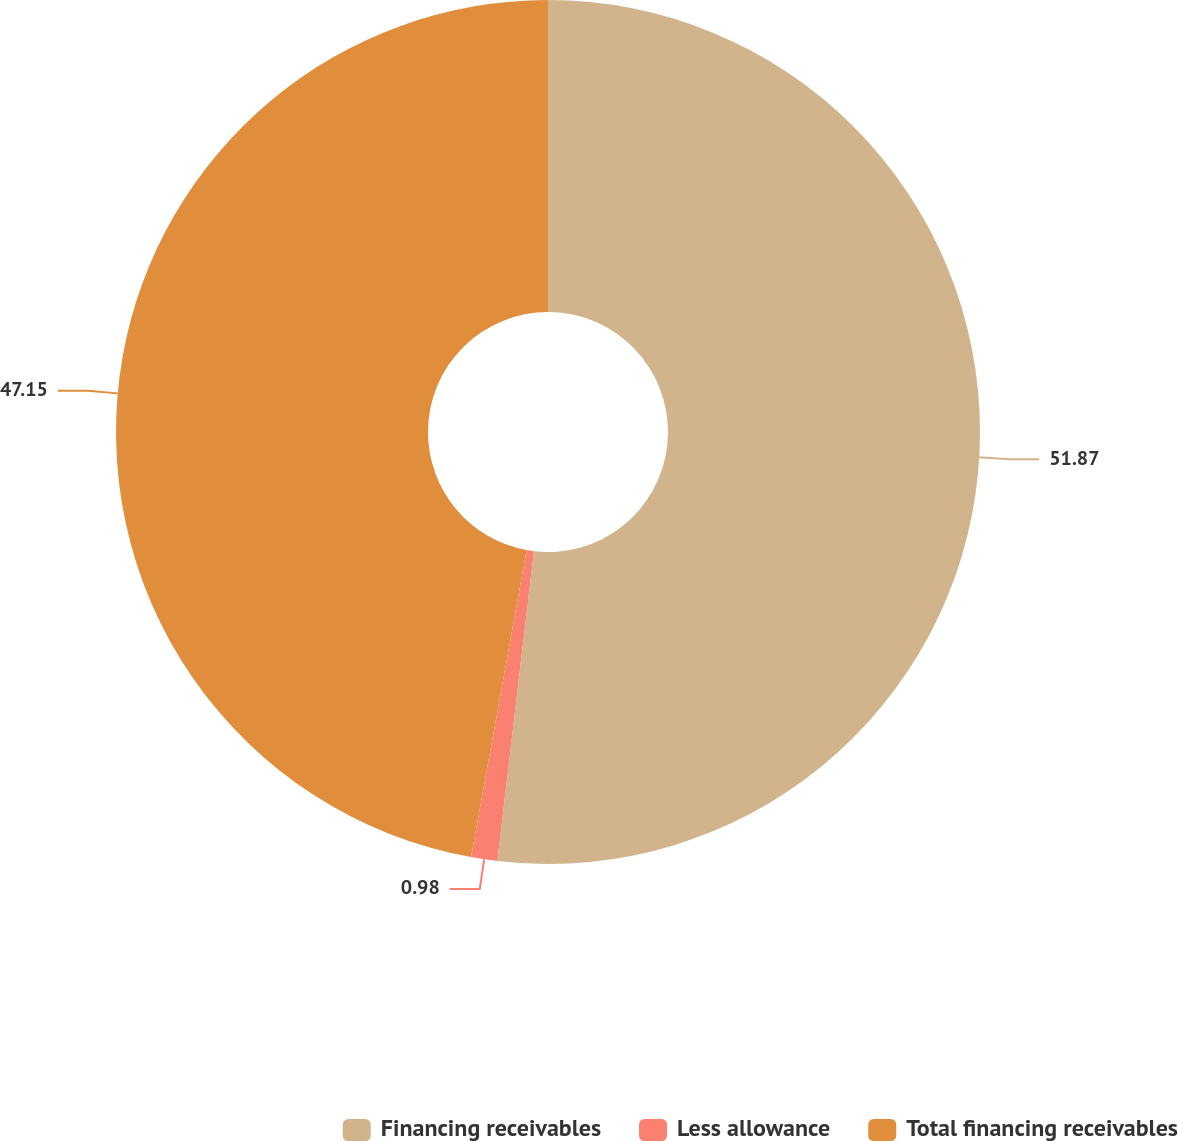<chart> <loc_0><loc_0><loc_500><loc_500><pie_chart><fcel>Financing receivables<fcel>Less allowance<fcel>Total financing receivables<nl><fcel>51.87%<fcel>0.98%<fcel>47.15%<nl></chart> 